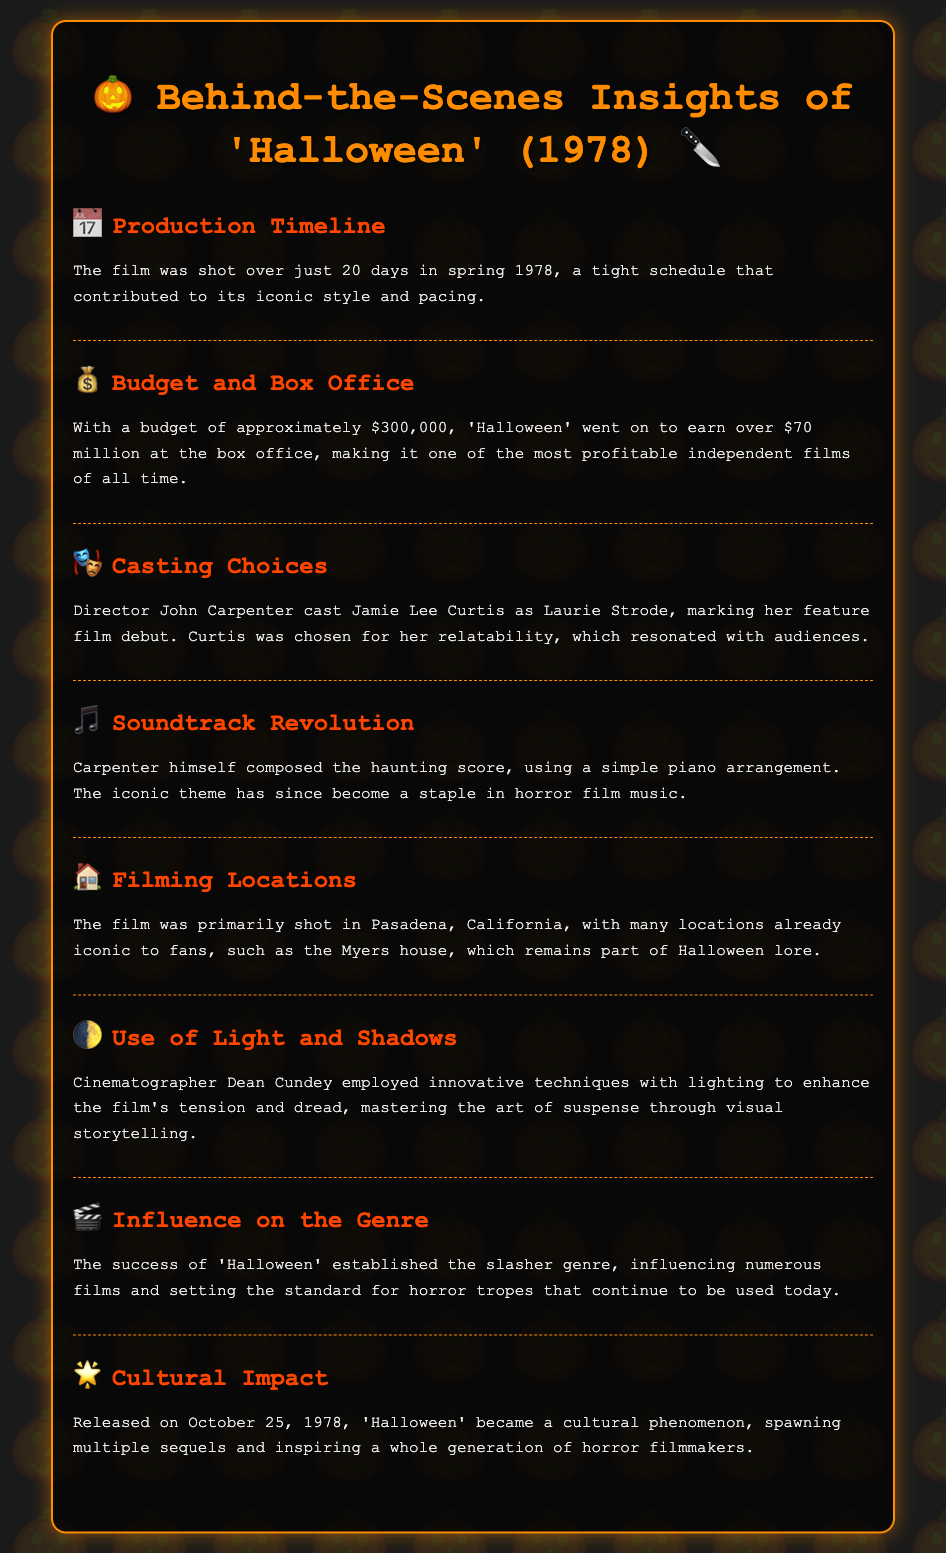What was the filming duration? The document states that the film was shot over just 20 days in spring 1978.
Answer: 20 days What was the budget of the film? The document mentions that the budget was approximately $300,000.
Answer: $300,000 Who composed the film's score? The document indicates that Carpenter himself composed the haunting score.
Answer: Carpenter Where was 'Halloween' primarily filmed? The document specifies that it was primarily shot in Pasadena, California.
Answer: Pasadena, California When was 'Halloween' released? The document states that it was released on October 25, 1978.
Answer: October 25, 1978 What impact did 'Halloween' have on filmmakers? The document mentions that it inspired a whole generation of horror filmmakers.
Answer: Inspired a whole generation of horror filmmakers Which actress made her feature film debut in 'Halloween'? The document notes that Jamie Lee Curtis made her feature film debut as Laurie Strode.
Answer: Jamie Lee Curtis What was the box office revenue for 'Halloween'? The document states it earned over $70 million at the box office.
Answer: Over $70 million 